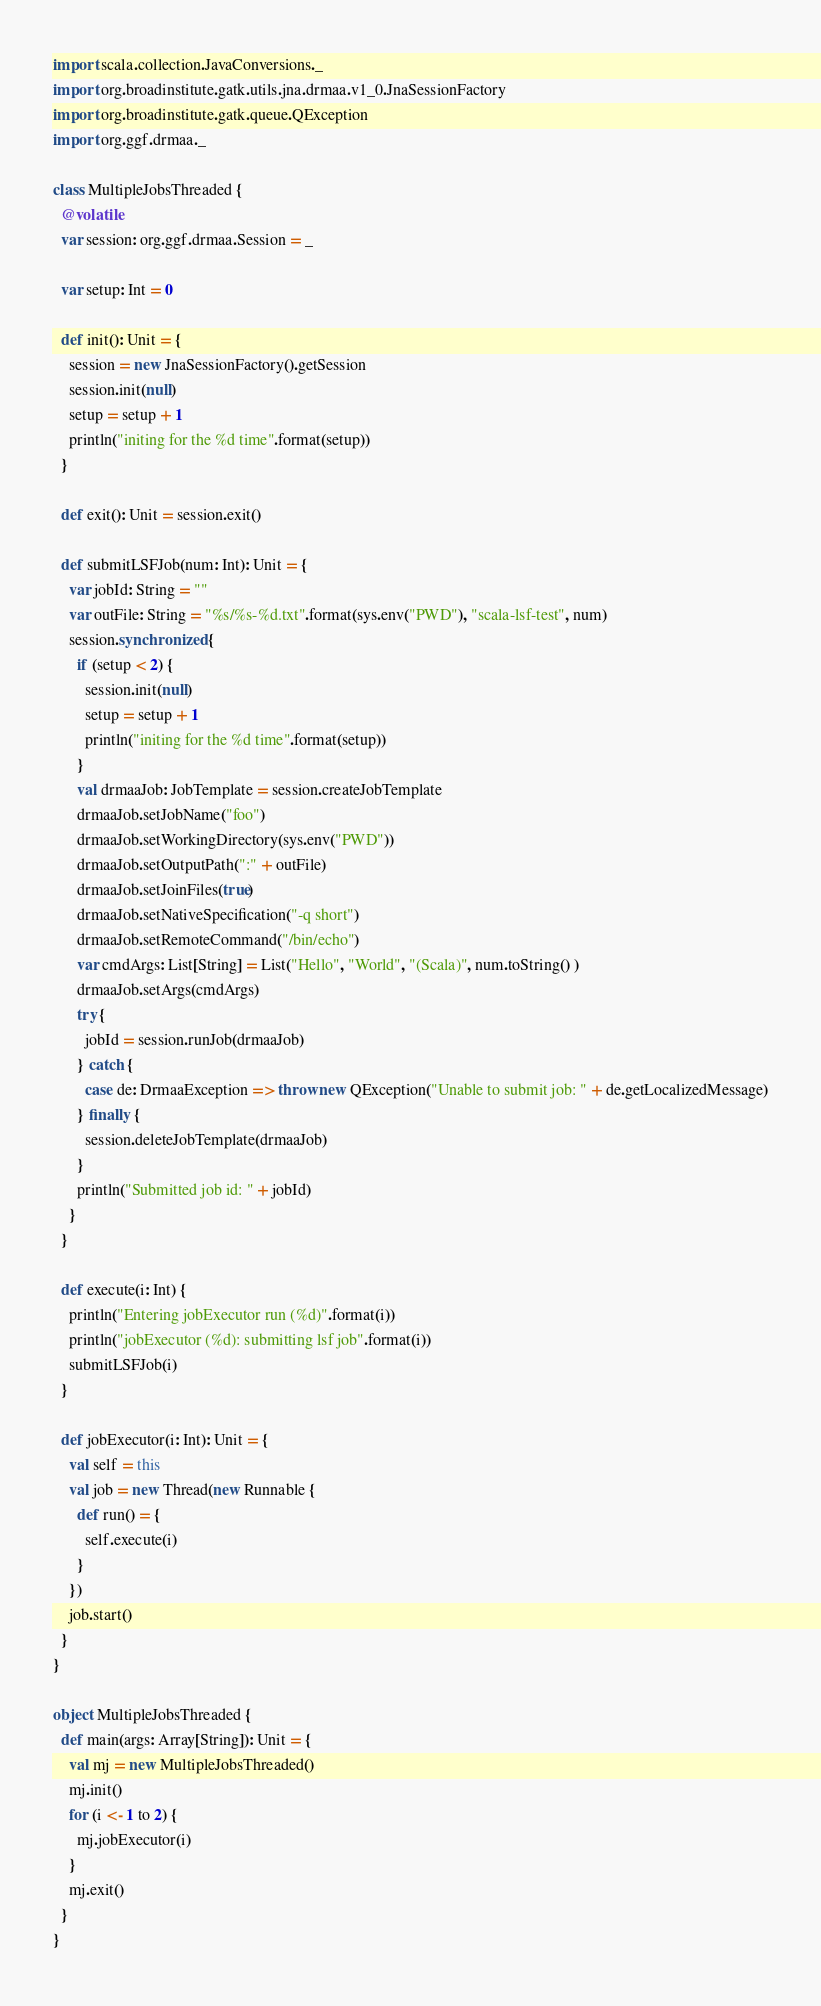<code> <loc_0><loc_0><loc_500><loc_500><_Scala_>import scala.collection.JavaConversions._
import org.broadinstitute.gatk.utils.jna.drmaa.v1_0.JnaSessionFactory
import org.broadinstitute.gatk.queue.QException
import org.ggf.drmaa._

class MultipleJobsThreaded {
  @volatile
  var session: org.ggf.drmaa.Session = _

  var setup: Int = 0

  def init(): Unit = {
    session = new JnaSessionFactory().getSession
    session.init(null)
    setup = setup + 1
    println("initing for the %d time".format(setup))
  }

  def exit(): Unit = session.exit()

  def submitLSFJob(num: Int): Unit = {
    var jobId: String = ""
    var outFile: String = "%s/%s-%d.txt".format(sys.env("PWD"), "scala-lsf-test", num)
    session.synchronized {
      if (setup < 2) {
        session.init(null)
        setup = setup + 1
        println("initing for the %d time".format(setup))
      }
      val drmaaJob: JobTemplate = session.createJobTemplate
      drmaaJob.setJobName("foo")
      drmaaJob.setWorkingDirectory(sys.env("PWD"))
      drmaaJob.setOutputPath(":" + outFile)
      drmaaJob.setJoinFiles(true)
      drmaaJob.setNativeSpecification("-q short")
      drmaaJob.setRemoteCommand("/bin/echo")
      var cmdArgs: List[String] = List("Hello", "World", "(Scala)", num.toString() )
      drmaaJob.setArgs(cmdArgs)
      try {
        jobId = session.runJob(drmaaJob)
      } catch {
        case de: DrmaaException => throw new QException("Unable to submit job: " + de.getLocalizedMessage)
      } finally {
        session.deleteJobTemplate(drmaaJob)
      }
      println("Submitted job id: " + jobId)
    }
  }

  def execute(i: Int) {
    println("Entering jobExecutor run (%d)".format(i))
    println("jobExecutor (%d): submitting lsf job".format(i))
    submitLSFJob(i)
  }

  def jobExecutor(i: Int): Unit = {
    val self = this
    val job = new Thread(new Runnable {
      def run() = {
        self.execute(i)
      }
    })
    job.start()
  }
}

object MultipleJobsThreaded {
  def main(args: Array[String]): Unit = {
    val mj = new MultipleJobsThreaded()
    mj.init()
    for (i <- 1 to 2) {
      mj.jobExecutor(i)
    }
    mj.exit()
  }
}
</code> 